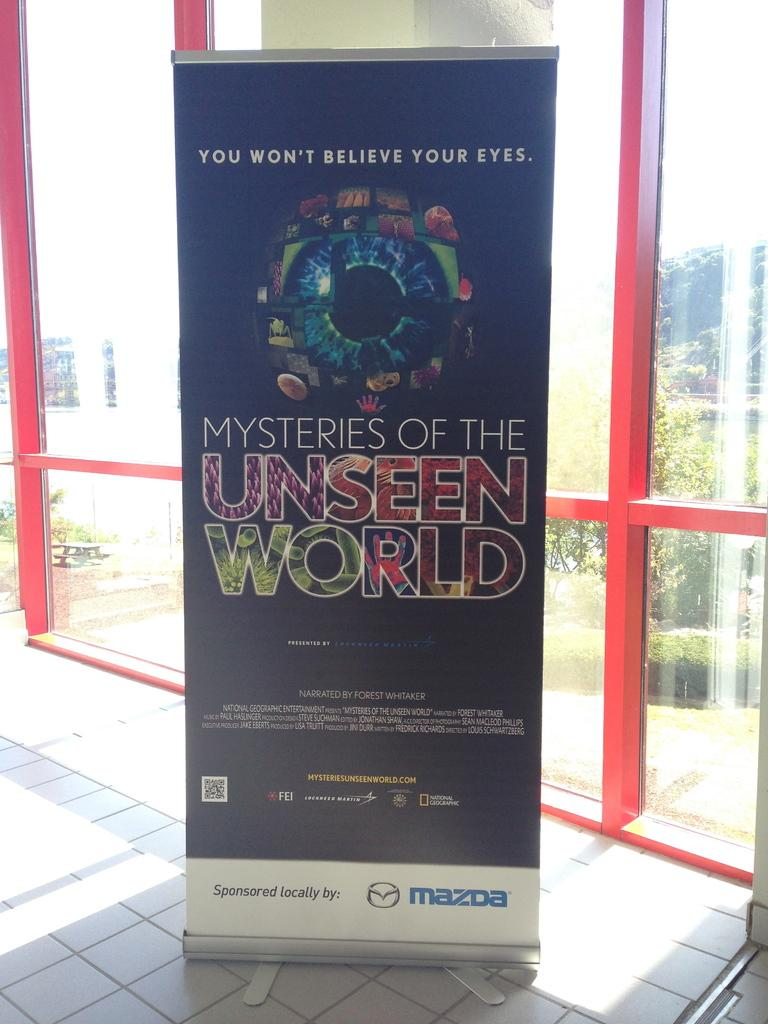<image>
Render a clear and concise summary of the photo. A black poster with an eyeball adverting Mysteries of the Unseen World. 